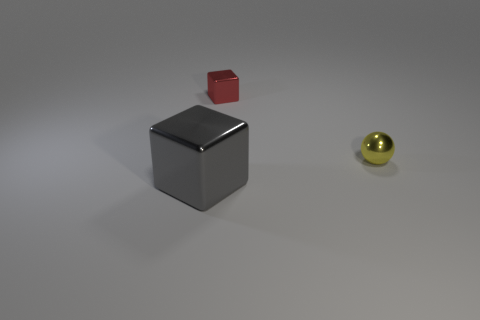There is a big shiny thing; does it have the same color as the small thing that is behind the tiny yellow ball?
Your answer should be very brief. No. There is a gray metallic cube; how many red things are behind it?
Keep it short and to the point. 1. Is the number of small objects less than the number of small yellow rubber spheres?
Offer a terse response. No. How big is the object that is both on the right side of the large cube and in front of the tiny red metal cube?
Your answer should be very brief. Small. Does the thing that is in front of the yellow object have the same color as the tiny metal block?
Keep it short and to the point. No. Are there fewer tiny shiny things that are in front of the large shiny object than yellow shiny cylinders?
Keep it short and to the point. No. What shape is the gray object that is the same material as the tiny block?
Ensure brevity in your answer.  Cube. Does the tiny yellow ball have the same material as the red cube?
Make the answer very short. Yes. Are there fewer metal blocks that are right of the large gray metal cube than big objects to the right of the small yellow metallic thing?
Your answer should be very brief. No. There is a shiny object on the right side of the block behind the large cube; how many large gray shiny blocks are behind it?
Offer a terse response. 0. 